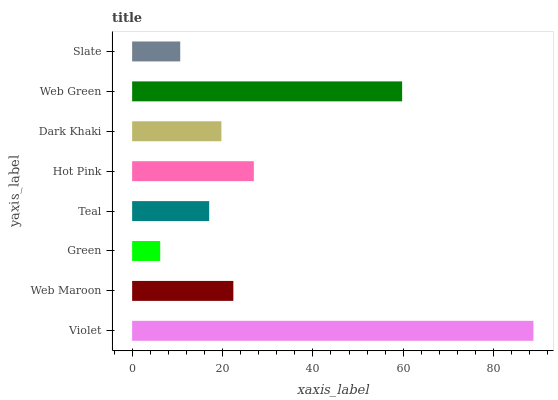Is Green the minimum?
Answer yes or no. Yes. Is Violet the maximum?
Answer yes or no. Yes. Is Web Maroon the minimum?
Answer yes or no. No. Is Web Maroon the maximum?
Answer yes or no. No. Is Violet greater than Web Maroon?
Answer yes or no. Yes. Is Web Maroon less than Violet?
Answer yes or no. Yes. Is Web Maroon greater than Violet?
Answer yes or no. No. Is Violet less than Web Maroon?
Answer yes or no. No. Is Web Maroon the high median?
Answer yes or no. Yes. Is Dark Khaki the low median?
Answer yes or no. Yes. Is Slate the high median?
Answer yes or no. No. Is Hot Pink the low median?
Answer yes or no. No. 